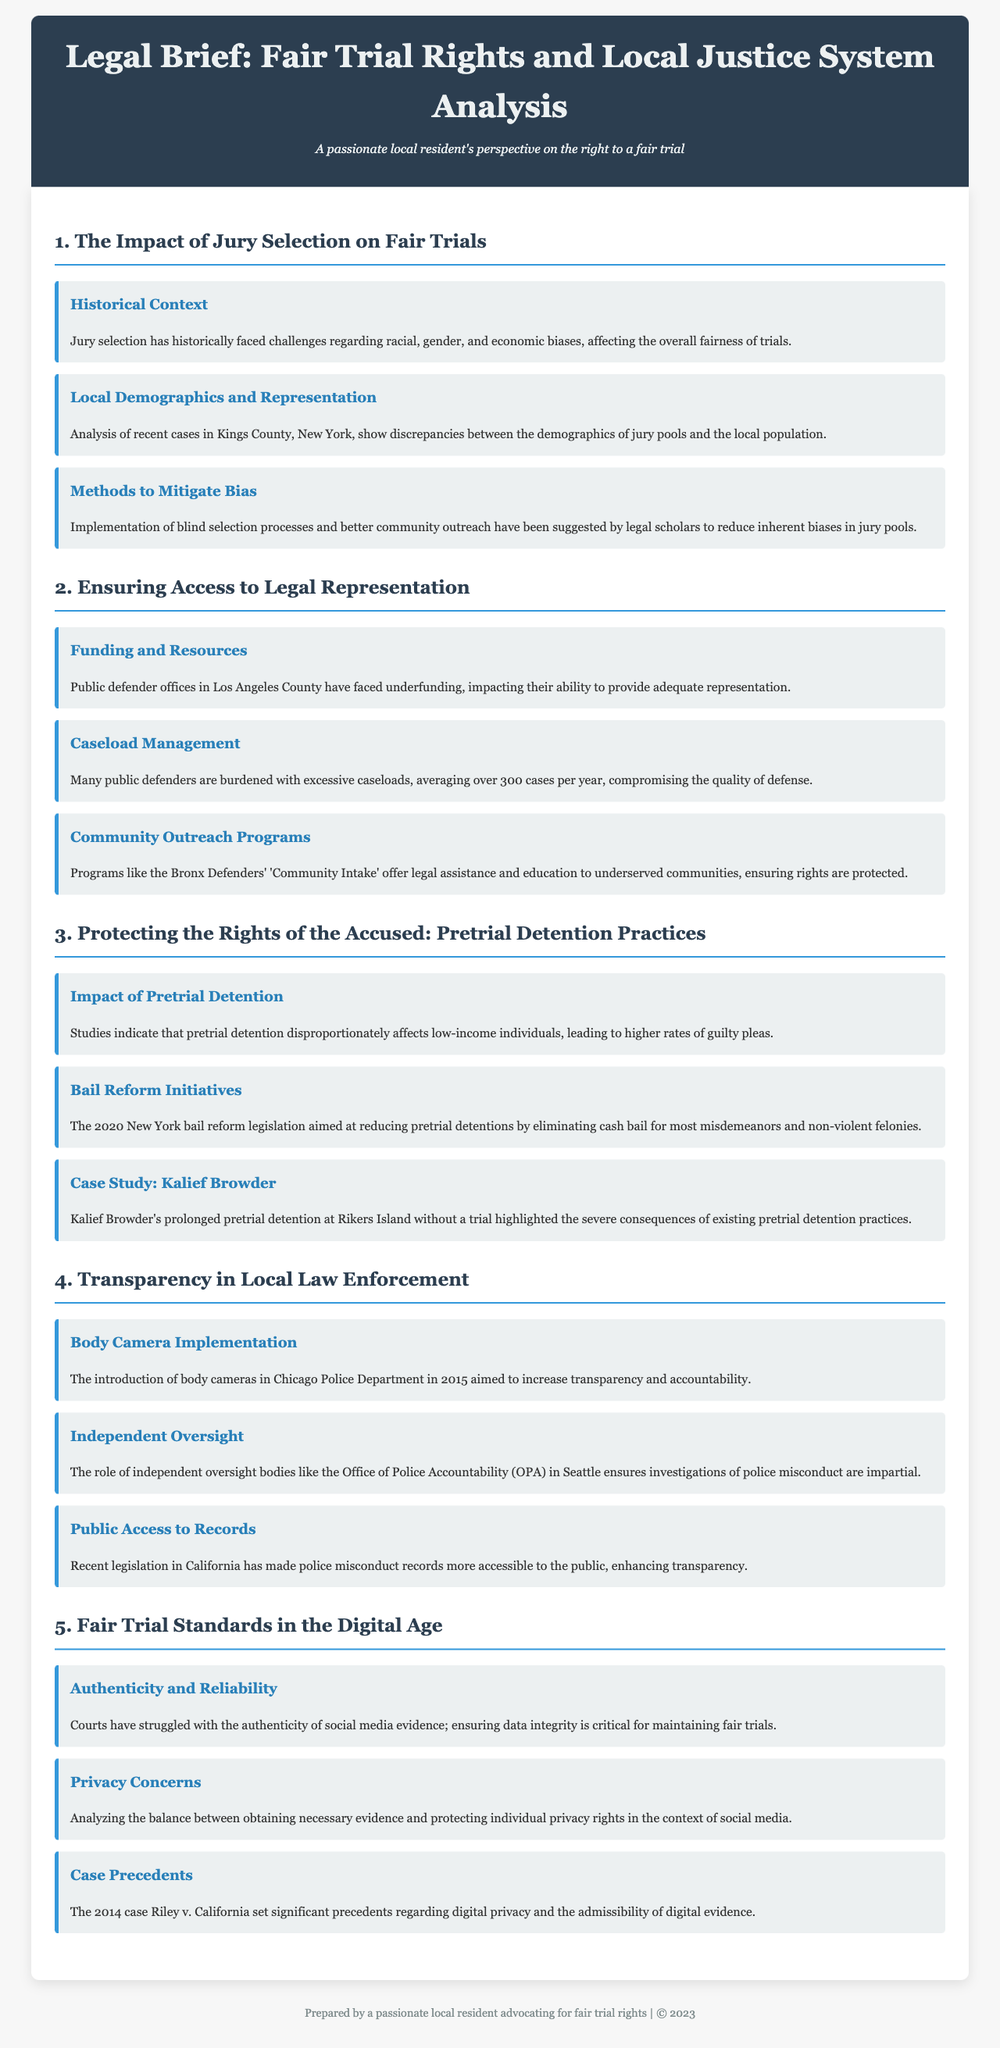what historical challenges have affected jury selection? The document states that jury selection has historically faced challenges regarding racial, gender, and economic biases.
Answer: racial, gender, and economic biases what demographic discrepancies were noted in Kings County, New York? The document mentions discrepancies between the demographics of jury pools and the local population.
Answer: demographics of jury pools and the local population how are public defender offices in Los Angeles County described? According to the document, public defender offices in Los Angeles County have faced underfunding, impacting their ability to provide adequate representation.
Answer: underfunding what is the average caseload for public defenders mentioned in the document? The document indicates that many public defenders are burdened with excessive caseloads, averaging over 300 cases per year.
Answer: over 300 cases per year what significant change did the 2020 New York bail reform legislation aim for? The document states that the bail reform legislation aimed at reducing pretrial detentions by eliminating cash bail for most misdemeanors and non-violent felonies.
Answer: eliminating cash bail what measure was implemented to increase transparency in the Chicago Police Department? The document notes that the introduction of body cameras in Chicago Police Department in 2015 aimed to increase transparency and accountability.
Answer: body cameras what is a key concern regarding social media evidence in court? The document highlights that courts have struggled with the authenticity of social media evidence; ensuring data integrity is critical for maintaining fair trials.
Answer: authenticity which case set precedents regarding digital privacy and evidence admissibility? The document refers to the 2014 case Riley v. California as significant in relation to digital privacy and the admissibility of digital evidence.
Answer: Riley v. California 